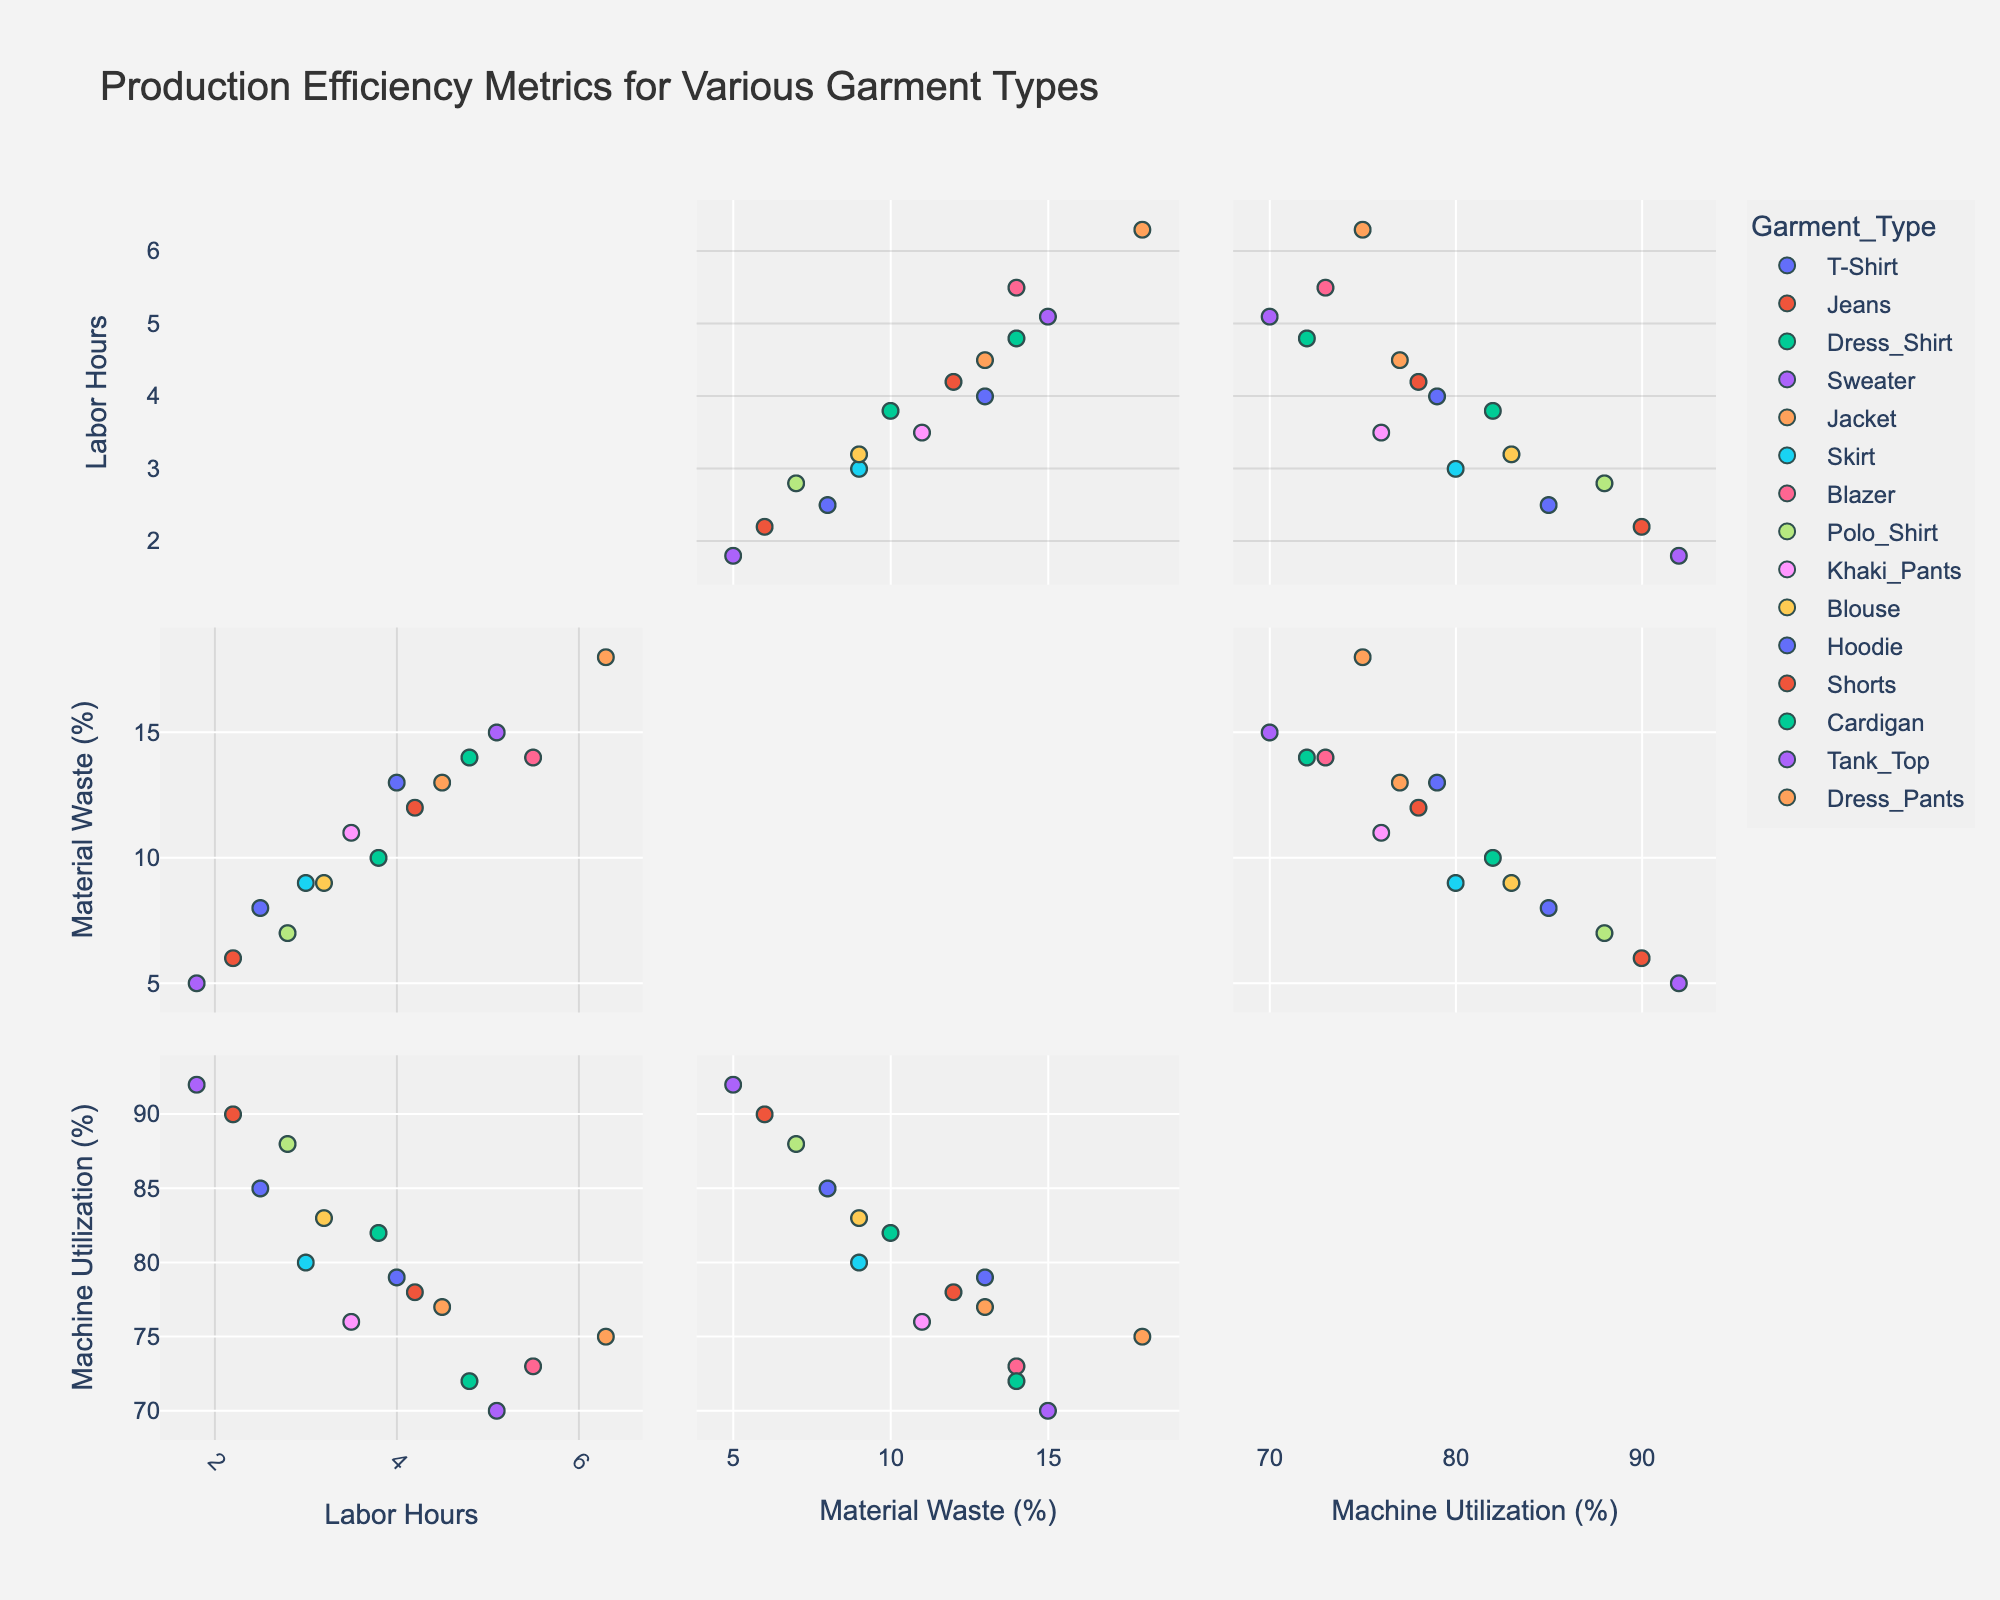What is the title of the scatterplot matrix? The title of the figure is usually located at the top center. Here, it reads "Production Efficiency Metrics for Various Garment Types".
Answer: Production Efficiency Metrics for Various Garment Types How many garment types are represented in the scatterplot matrix? Count the number of unique colors/labels representing different garment types. Based on the legend, there are 15 unique garment types.
Answer: 15 Which garment type has the lowest labor hours? Locate the point with the smallest 'Labor Hours' value along the 'Labor_Hours' axis in the scatterplot matrix. The garment with the value around 1.8 is Tank Top.
Answer: Tank Top Compare the Machine Utilization Rate between T-Shirts and Shorts. Which has a higher rate? Identify the points representing T-Shirts and Shorts. T-Shirts hover around 85%, while Shorts are around 90%.
Answer: Shorts What are the dimensions used in the scatterplot matrix? The scatterplot matrix compares data dimensions visible on the x and y-axes. Here, they are 'Labor Hours', 'Material Waste (%)', and 'Machine Utilization (%)'.
Answer: Labor Hours, Material Waste (%), Machine Utilization (%) Which garment type shows the highest machine utilization rate? Locate the point with the highest 'Machine Utilization (%)' value along the 'Machine_Utilization_Rate' axis. The top value of around 92% corresponds to Tank Top.
Answer: Tank Top What is the average material waste percentage for the garments Jeans, Jacket, and Hoodie? Identify the 'Material Waste (%)' values for Jeans (12), Jacket (18), and Hoodie (13). Calculate the average: (12 + 18 + 13) / 3 = 43 / 3 ≈ 14.33%.
Answer: 14.33% Which garment type has the highest labor hours and what is this value? Find the point with the highest value along the 'Labor Hours' axis. The garment with the highest labor hours, around 6.3, is Jacket.
Answer: Jacket Are there any garment types that fall below 10% material waste, have labor hours less than 3, and have machine utilization rates above 85%? Locate points that satisfy all three conditions in their respective axis intersections. Tank Top has material waste (5%), labor hours (1.8), and machine utilization (92%).
Answer: Tank Top How does the material waste of Blazers compare to that of Cardigans? Identify the 'Material Waste (%)' values. Blazers have a value around 14%, while Cardigans also hover around 14%. Both have similar values.
Answer: Both are similar 